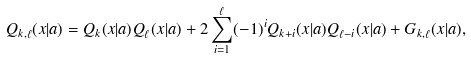Convert formula to latex. <formula><loc_0><loc_0><loc_500><loc_500>Q _ { k , \ell } ( x | a ) = Q _ { k } ( x | a ) Q _ { \ell } ( x | a ) + 2 \sum _ { i = 1 } ^ { \ell } ( - 1 ) ^ { i } Q _ { k + i } ( x | a ) Q _ { \ell - i } ( x | a ) + G _ { k , \ell } ( x | a ) ,</formula> 